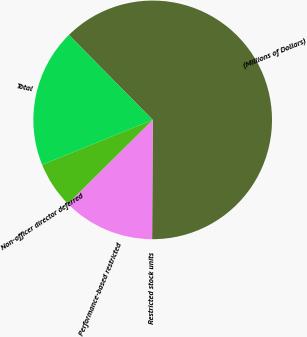Convert chart. <chart><loc_0><loc_0><loc_500><loc_500><pie_chart><fcel>(Millions of Dollars)<fcel>Restricted stock units<fcel>Performance-based restricted<fcel>Non-officer director deferred<fcel>Total<nl><fcel>62.43%<fcel>0.03%<fcel>12.51%<fcel>6.27%<fcel>18.75%<nl></chart> 